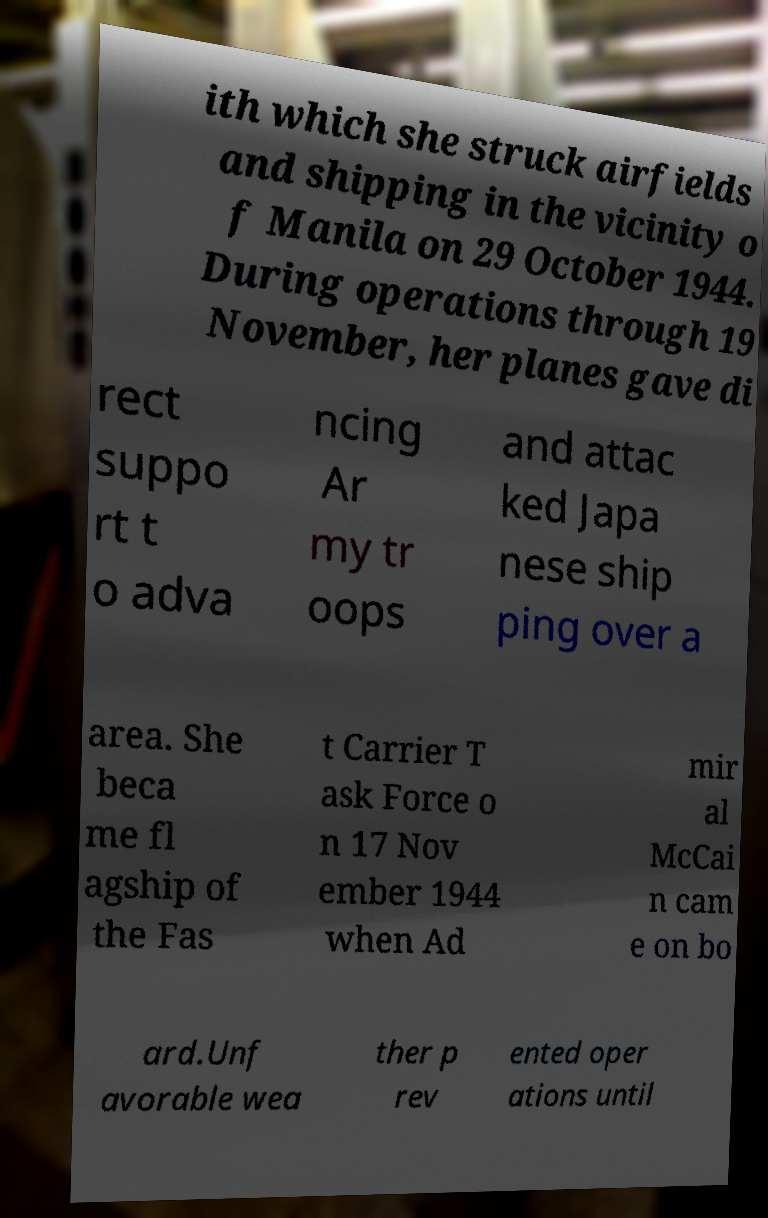Please identify and transcribe the text found in this image. ith which she struck airfields and shipping in the vicinity o f Manila on 29 October 1944. During operations through 19 November, her planes gave di rect suppo rt t o adva ncing Ar my tr oops and attac ked Japa nese ship ping over a area. She beca me fl agship of the Fas t Carrier T ask Force o n 17 Nov ember 1944 when Ad mir al McCai n cam e on bo ard.Unf avorable wea ther p rev ented oper ations until 